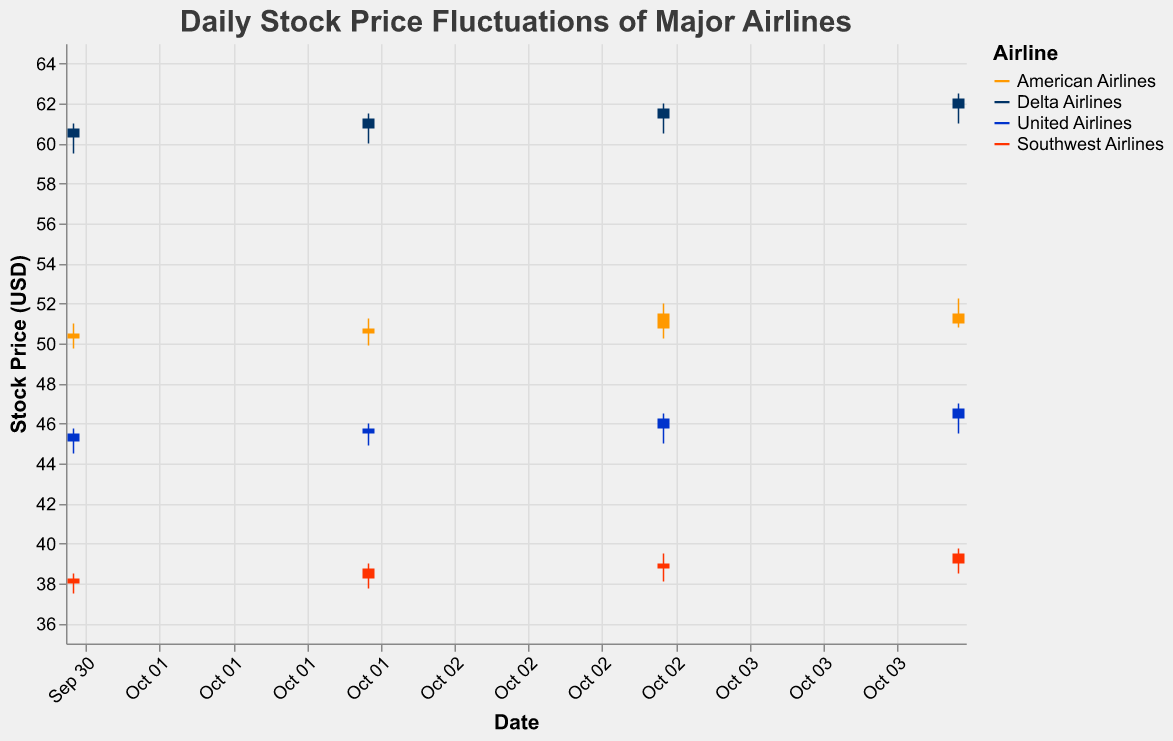Which airline has the highest stock price on October 3, 2022? On October 3, 2022, the stock prices of American Airlines (Close: 51.50), Delta Airlines (Close: 61.75), United Airlines (Close: 46.25), and Southwest Airlines (Close: 39.00) are shown. Delta Airlines has the highest closing price on that date.
Answer: Delta Airlines What is the range of stock prices for United Airlines on October 2, 2022? The range is calculated by subtracting the low price (44.90) from the high price (46.00) for United Airlines on October 2, 2022. The range is 46.00 - 44.90 = 1.10.
Answer: 1.10 Which airline showed the greatest daily fluctuation (High-Low) on October 1, 2022? On October 1, 2022, the fluctuations can be calculated for each airline: American Airlines (51.00 - 49.75 = 1.25), Delta Airlines (61.00 - 59.50 = 1.50), United Airlines (45.75 - 44.50 = 1.25), Southwest Airlines (38.50 - 37.50 = 1.00). Delta Airlines showed the greatest fluctuation.
Answer: Delta Airlines What was the lowest closing price among all airlines between October 1 and October 4, 2022? Examining the closing prices, the lowest closing price among all airlines is Southwest Airlines on October 1, 2022, at 38.25.
Answer: 38.25 How many airlines have a stock price above 50 on October 4, 2022? On October 4, 2022, the closing prices are American Airlines (51.00), Delta Airlines (62.25), United Airlines (46.75), Southwest Airlines (39.50). Only two airlines, American Airlines and Delta Airlines, have closing prices above 50.
Answer: 2 What is the average closing price of Southwest Airlines over the four days? The closing prices for Southwest Airlines over the four days are 38.25, 38.75, 39.00, and 39.50. The average is calculated as (38.25 + 38.75 + 39.00 + 39.50) / 4 = 38.875.
Answer: 38.875 Which airline had the highest trading volume on October 1, 2022? The trading volumes on October 1, 2022, are American Airlines (700,000), Delta Airlines (900,000), United Airlines (650,000), Southwest Airlines (500,000). Delta Airlines had the highest trading volume.
Answer: Delta Airlines What is the difference in closing prices between Delta Airlines and Southwest Airlines on October 4, 2022? The closing prices on October 4, 2022, are Delta Airlines (62.25) and Southwest Airlines (39.50). The difference is 62.25 - 39.50 = 22.75.
Answer: 22.75 